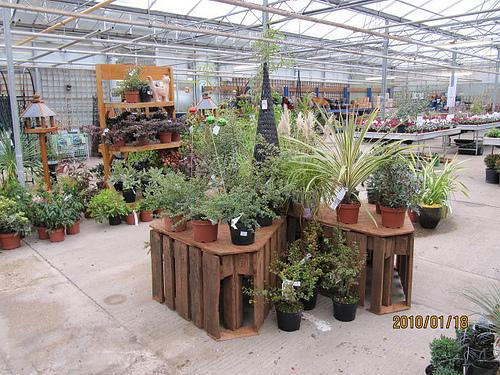Is this a plant nursery?
Be succinct. Yes. Are the plants all the same?
Short answer required. No. When was this photo taken?
Be succinct. 2010. 